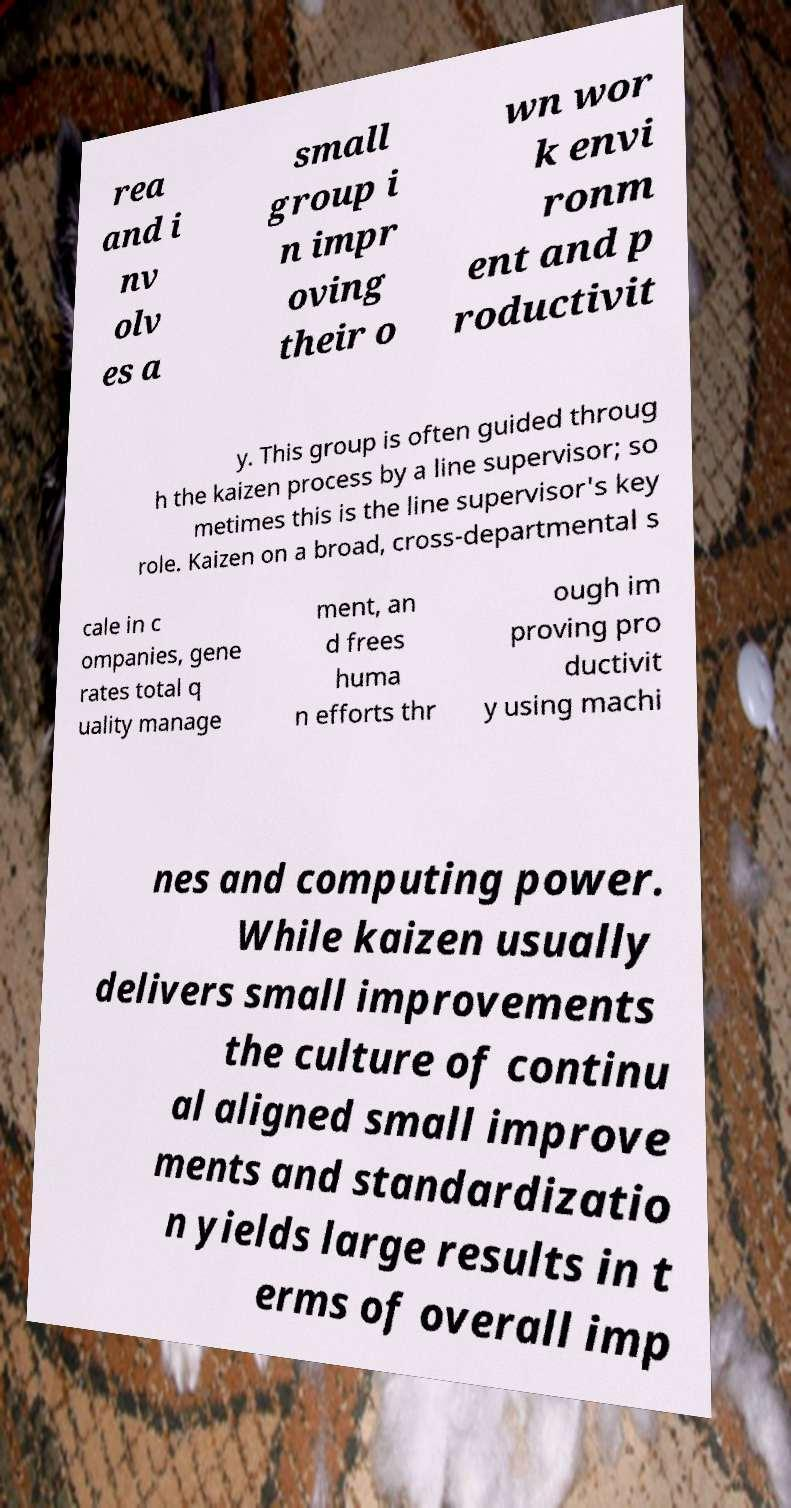Please read and relay the text visible in this image. What does it say? rea and i nv olv es a small group i n impr oving their o wn wor k envi ronm ent and p roductivit y. This group is often guided throug h the kaizen process by a line supervisor; so metimes this is the line supervisor's key role. Kaizen on a broad, cross-departmental s cale in c ompanies, gene rates total q uality manage ment, an d frees huma n efforts thr ough im proving pro ductivit y using machi nes and computing power. While kaizen usually delivers small improvements the culture of continu al aligned small improve ments and standardizatio n yields large results in t erms of overall imp 